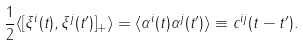<formula> <loc_0><loc_0><loc_500><loc_500>\frac { 1 } { 2 } \langle [ \xi ^ { i } ( t ) , \xi ^ { j } ( t ^ { \prime } ) ] _ { + } \rangle = \langle \alpha ^ { i } ( t ) \alpha ^ { j } ( t ^ { \prime } ) \rangle \equiv c ^ { i j } ( t - t ^ { \prime } ) .</formula> 